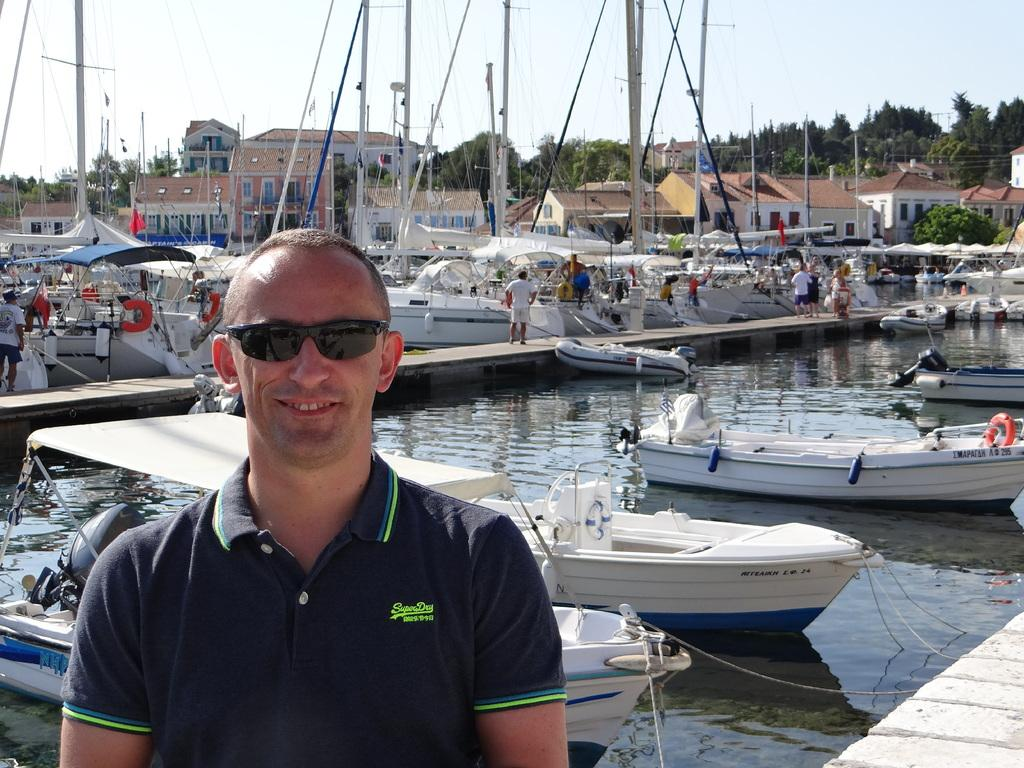What is the main subject in the foreground of the image? There is a person in the foreground of the image. What is the person wearing on their upper body? The person is wearing a T-shirt. What type of eyewear is the person wearing? The person is wearing sunglasses. What can be seen in the background of the image? There are boats, water, people, houses, trees, and the sky visible in the background of the image. How many brothers are visible in the image? There is no mention of brothers in the image, so it cannot be determined from the provided facts. What type of apparatus is being used by the person in the image? There is no apparatus visible in the image; the person is simply standing in the foreground. Is there a banana in the person's hand in the image? There is no banana visible in the image; the person is not holding any object. 